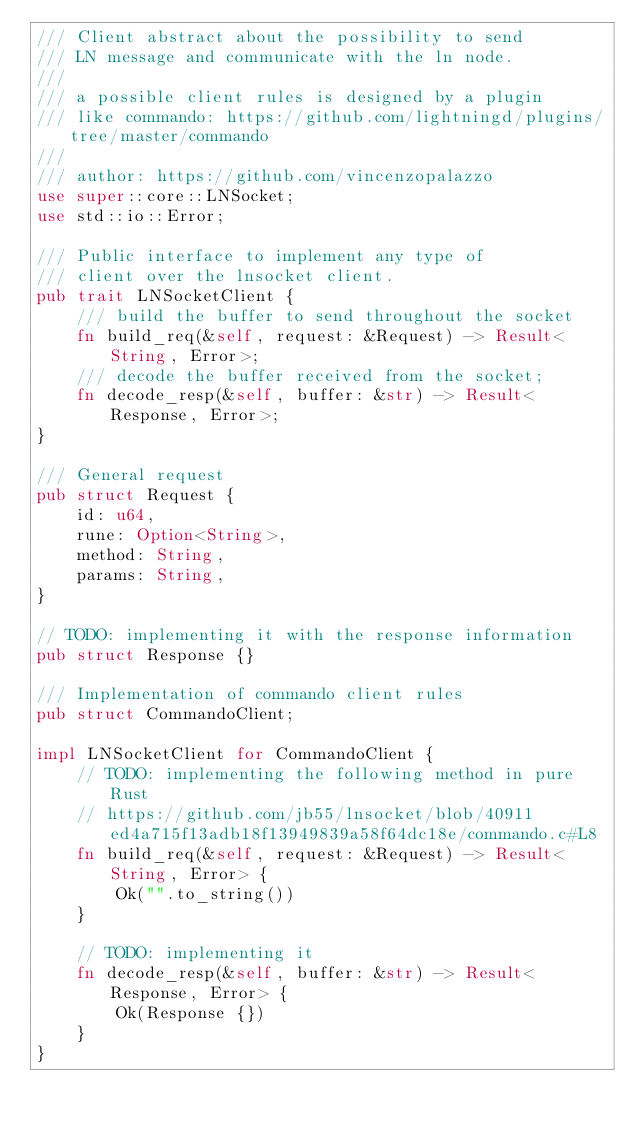Convert code to text. <code><loc_0><loc_0><loc_500><loc_500><_Rust_>/// Client abstract about the possibility to send
/// LN message and communicate with the ln node.
///
/// a possible client rules is designed by a plugin
/// like commando: https://github.com/lightningd/plugins/tree/master/commando
///
/// author: https://github.com/vincenzopalazzo
use super::core::LNSocket;
use std::io::Error;

/// Public interface to implement any type of
/// client over the lnsocket client.
pub trait LNSocketClient {
    /// build the buffer to send throughout the socket
    fn build_req(&self, request: &Request) -> Result<String, Error>;
    /// decode the buffer received from the socket;
    fn decode_resp(&self, buffer: &str) -> Result<Response, Error>;
}

/// General request
pub struct Request {
    id: u64,
    rune: Option<String>,
    method: String,
    params: String,
}

// TODO: implementing it with the response information
pub struct Response {}

/// Implementation of commando client rules
pub struct CommandoClient;

impl LNSocketClient for CommandoClient {
    // TODO: implementing the following method in pure Rust
    // https://github.com/jb55/lnsocket/blob/40911ed4a715f13adb18f13949839a58f64dc18e/commando.c#L8
    fn build_req(&self, request: &Request) -> Result<String, Error> {
        Ok("".to_string())
    }

    // TODO: implementing it
    fn decode_resp(&self, buffer: &str) -> Result<Response, Error> {
        Ok(Response {})
    }
}
</code> 